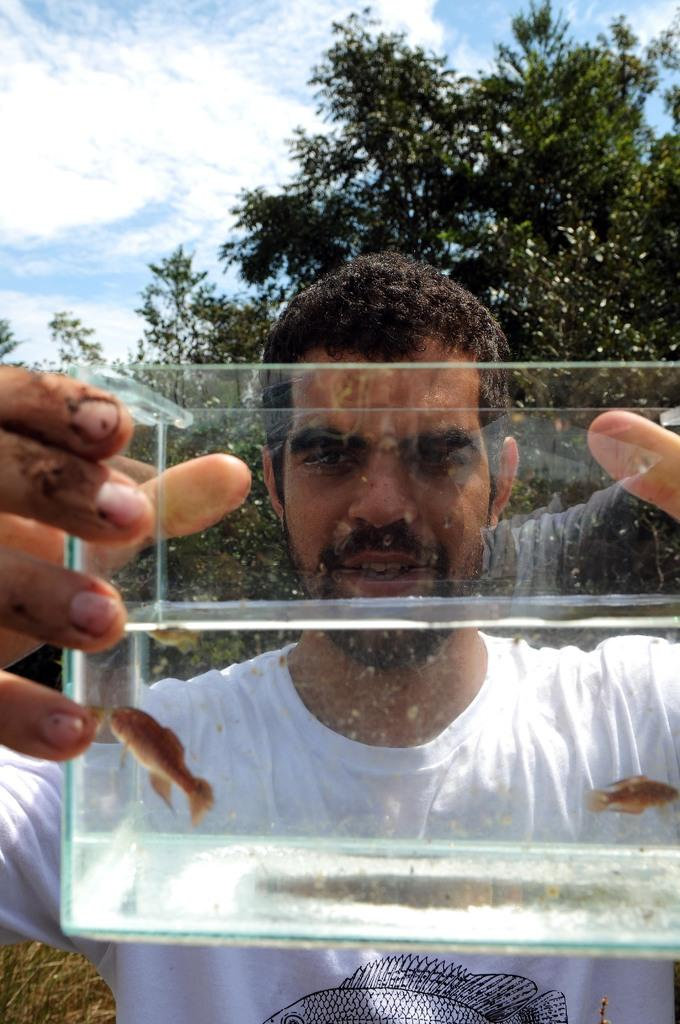Who is present in the image? There is a man in the image. What is the man wearing? The man is wearing a white t-shirt. What type of natural environment is visible in the image? There are trees in the image. What can be seen in the skyward in the image? The sky is visible in the image, and there are clouds in the sky. What is the best route to take to avoid the lumber in the image? There is no lumber present in the image, so there is no need to avoid it. 